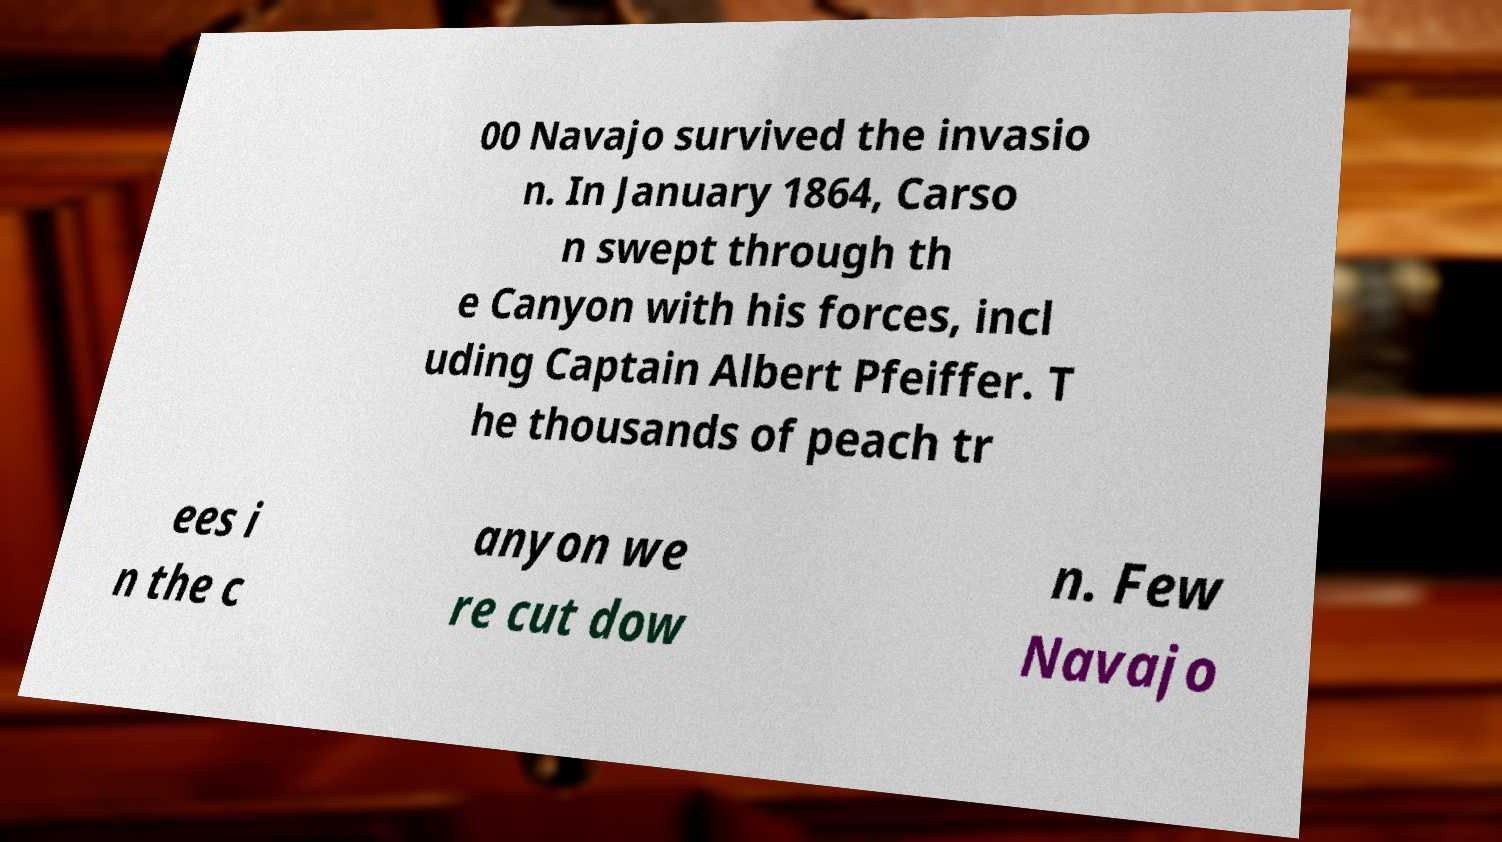Can you accurately transcribe the text from the provided image for me? 00 Navajo survived the invasio n. In January 1864, Carso n swept through th e Canyon with his forces, incl uding Captain Albert Pfeiffer. T he thousands of peach tr ees i n the c anyon we re cut dow n. Few Navajo 